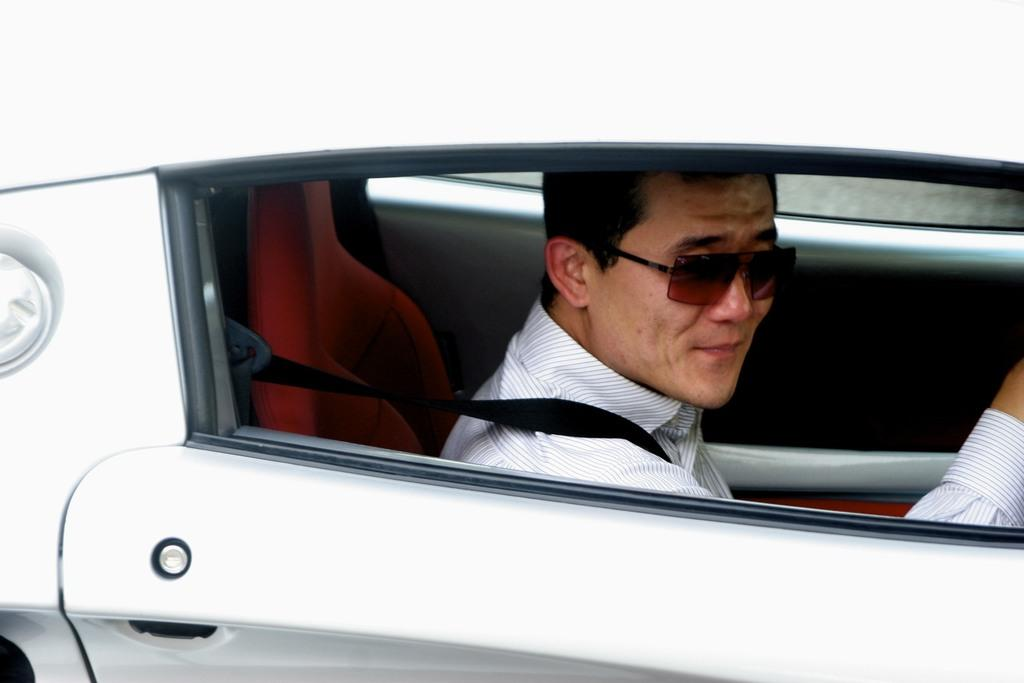Who is present in the image? There is a man in the image. What is the man wearing in the image? The man is wearing goggles in the image. Where is the man located in the image? The man is sitting inside a car in the image. What type of lamp is the man using to exchange information with the other person in the image? There is no lamp or exchange of information present in the image; it only features a man wearing goggles and sitting inside a car. 